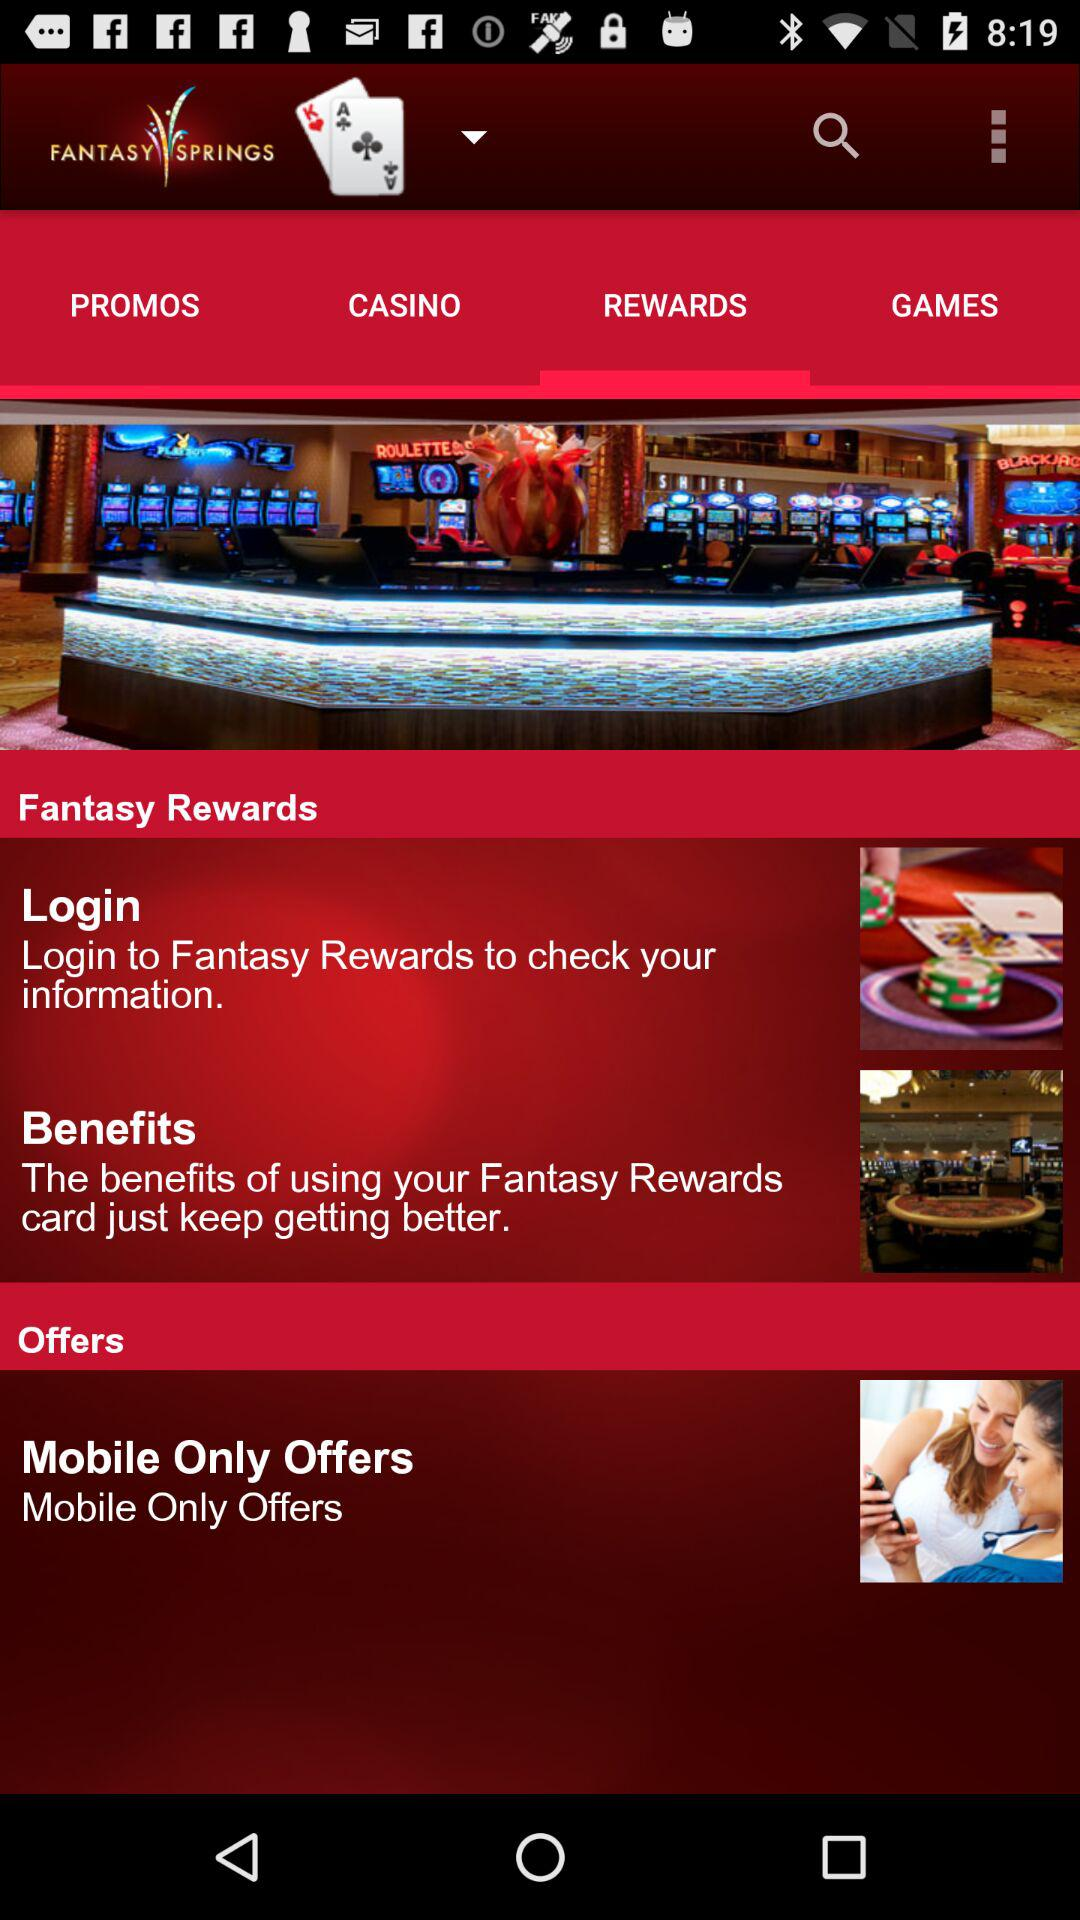Which tab is selected? The selected tab is "REWARDS". 